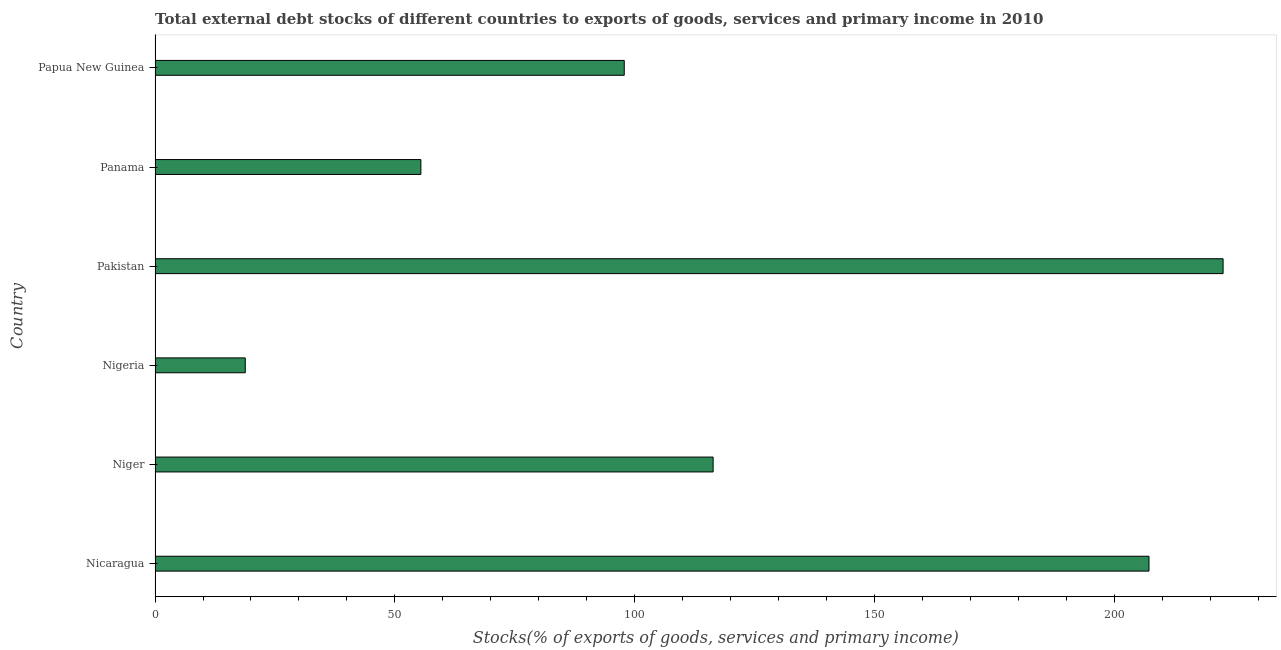Does the graph contain any zero values?
Give a very brief answer. No. What is the title of the graph?
Provide a short and direct response. Total external debt stocks of different countries to exports of goods, services and primary income in 2010. What is the label or title of the X-axis?
Make the answer very short. Stocks(% of exports of goods, services and primary income). What is the label or title of the Y-axis?
Make the answer very short. Country. What is the external debt stocks in Niger?
Keep it short and to the point. 116.37. Across all countries, what is the maximum external debt stocks?
Offer a very short reply. 222.71. Across all countries, what is the minimum external debt stocks?
Give a very brief answer. 18.81. In which country was the external debt stocks minimum?
Make the answer very short. Nigeria. What is the sum of the external debt stocks?
Offer a terse response. 718.43. What is the difference between the external debt stocks in Nigeria and Papua New Guinea?
Provide a short and direct response. -79.03. What is the average external debt stocks per country?
Make the answer very short. 119.74. What is the median external debt stocks?
Offer a terse response. 107.11. What is the ratio of the external debt stocks in Nicaragua to that in Panama?
Give a very brief answer. 3.74. Is the external debt stocks in Nicaragua less than that in Nigeria?
Offer a very short reply. No. Is the difference between the external debt stocks in Panama and Papua New Guinea greater than the difference between any two countries?
Ensure brevity in your answer.  No. What is the difference between the highest and the second highest external debt stocks?
Make the answer very short. 15.45. Is the sum of the external debt stocks in Panama and Papua New Guinea greater than the maximum external debt stocks across all countries?
Your answer should be very brief. No. What is the difference between the highest and the lowest external debt stocks?
Provide a succinct answer. 203.9. How many countries are there in the graph?
Your answer should be compact. 6. What is the Stocks(% of exports of goods, services and primary income) in Nicaragua?
Your answer should be compact. 207.26. What is the Stocks(% of exports of goods, services and primary income) in Niger?
Give a very brief answer. 116.37. What is the Stocks(% of exports of goods, services and primary income) of Nigeria?
Your answer should be very brief. 18.81. What is the Stocks(% of exports of goods, services and primary income) of Pakistan?
Provide a succinct answer. 222.71. What is the Stocks(% of exports of goods, services and primary income) in Panama?
Offer a very short reply. 55.43. What is the Stocks(% of exports of goods, services and primary income) of Papua New Guinea?
Provide a short and direct response. 97.84. What is the difference between the Stocks(% of exports of goods, services and primary income) in Nicaragua and Niger?
Give a very brief answer. 90.89. What is the difference between the Stocks(% of exports of goods, services and primary income) in Nicaragua and Nigeria?
Offer a very short reply. 188.45. What is the difference between the Stocks(% of exports of goods, services and primary income) in Nicaragua and Pakistan?
Provide a short and direct response. -15.45. What is the difference between the Stocks(% of exports of goods, services and primary income) in Nicaragua and Panama?
Keep it short and to the point. 151.83. What is the difference between the Stocks(% of exports of goods, services and primary income) in Nicaragua and Papua New Guinea?
Provide a succinct answer. 109.42. What is the difference between the Stocks(% of exports of goods, services and primary income) in Niger and Nigeria?
Offer a terse response. 97.56. What is the difference between the Stocks(% of exports of goods, services and primary income) in Niger and Pakistan?
Provide a succinct answer. -106.34. What is the difference between the Stocks(% of exports of goods, services and primary income) in Niger and Panama?
Your response must be concise. 60.94. What is the difference between the Stocks(% of exports of goods, services and primary income) in Niger and Papua New Guinea?
Your response must be concise. 18.53. What is the difference between the Stocks(% of exports of goods, services and primary income) in Nigeria and Pakistan?
Give a very brief answer. -203.9. What is the difference between the Stocks(% of exports of goods, services and primary income) in Nigeria and Panama?
Keep it short and to the point. -36.62. What is the difference between the Stocks(% of exports of goods, services and primary income) in Nigeria and Papua New Guinea?
Provide a short and direct response. -79.03. What is the difference between the Stocks(% of exports of goods, services and primary income) in Pakistan and Panama?
Provide a short and direct response. 167.29. What is the difference between the Stocks(% of exports of goods, services and primary income) in Pakistan and Papua New Guinea?
Offer a very short reply. 124.87. What is the difference between the Stocks(% of exports of goods, services and primary income) in Panama and Papua New Guinea?
Offer a terse response. -42.41. What is the ratio of the Stocks(% of exports of goods, services and primary income) in Nicaragua to that in Niger?
Your answer should be compact. 1.78. What is the ratio of the Stocks(% of exports of goods, services and primary income) in Nicaragua to that in Nigeria?
Provide a short and direct response. 11.02. What is the ratio of the Stocks(% of exports of goods, services and primary income) in Nicaragua to that in Pakistan?
Your answer should be very brief. 0.93. What is the ratio of the Stocks(% of exports of goods, services and primary income) in Nicaragua to that in Panama?
Make the answer very short. 3.74. What is the ratio of the Stocks(% of exports of goods, services and primary income) in Nicaragua to that in Papua New Guinea?
Offer a very short reply. 2.12. What is the ratio of the Stocks(% of exports of goods, services and primary income) in Niger to that in Nigeria?
Provide a short and direct response. 6.19. What is the ratio of the Stocks(% of exports of goods, services and primary income) in Niger to that in Pakistan?
Ensure brevity in your answer.  0.52. What is the ratio of the Stocks(% of exports of goods, services and primary income) in Niger to that in Papua New Guinea?
Ensure brevity in your answer.  1.19. What is the ratio of the Stocks(% of exports of goods, services and primary income) in Nigeria to that in Pakistan?
Ensure brevity in your answer.  0.08. What is the ratio of the Stocks(% of exports of goods, services and primary income) in Nigeria to that in Panama?
Keep it short and to the point. 0.34. What is the ratio of the Stocks(% of exports of goods, services and primary income) in Nigeria to that in Papua New Guinea?
Give a very brief answer. 0.19. What is the ratio of the Stocks(% of exports of goods, services and primary income) in Pakistan to that in Panama?
Your response must be concise. 4.02. What is the ratio of the Stocks(% of exports of goods, services and primary income) in Pakistan to that in Papua New Guinea?
Offer a very short reply. 2.28. What is the ratio of the Stocks(% of exports of goods, services and primary income) in Panama to that in Papua New Guinea?
Your answer should be compact. 0.57. 